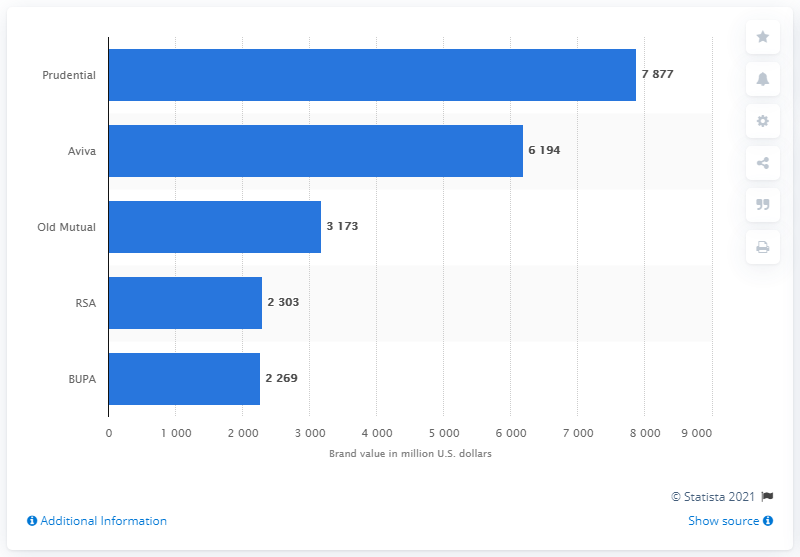Can you tell me more about the source of this information? The source of the information is Statista, a reputable company specializing in market and consumer data. The chart indicates the year 2021, suggesting this data is reflective of the brand values for the year specified. 